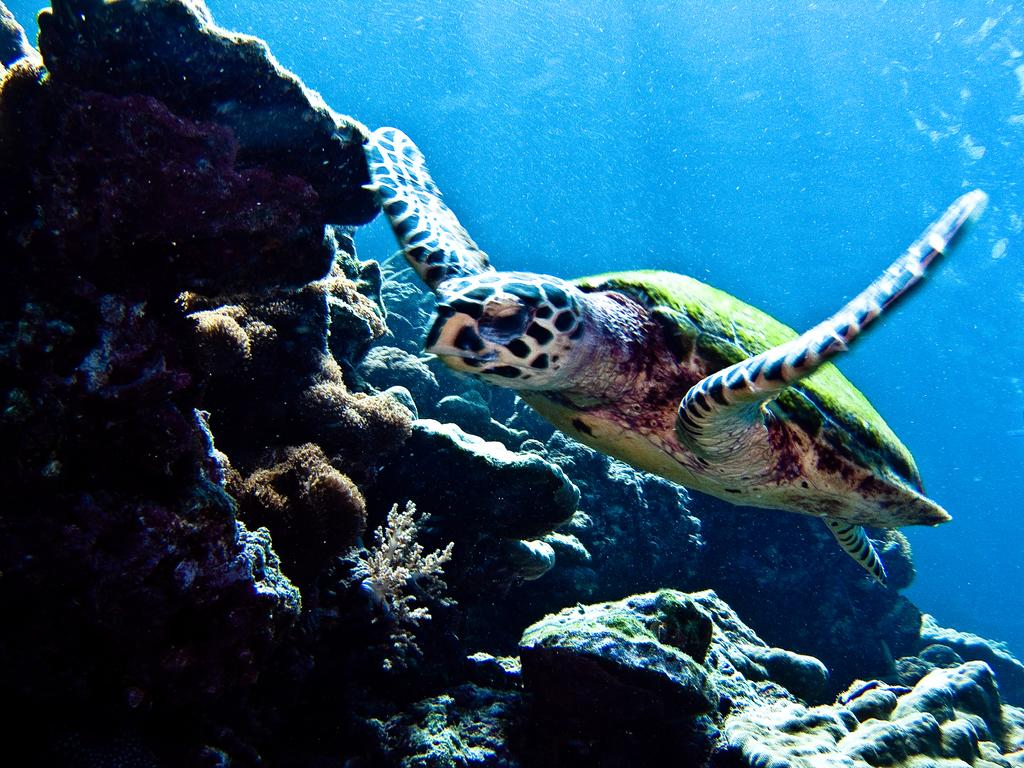What animal is present in the image? There is a turtle in the image. What is the turtle doing in the image? The turtle is swimming in the water. What type of natural features can be seen in the image? There are rocks and plants visible in the image. What type of coal can be seen in the image? There is no coal present in the image; it features a turtle swimming in the water with rocks and plants visible. How many waves can be seen crashing against the rocks in the image? There are no waves present in the image; it features a turtle swimming in the water with rocks and plants visible. 